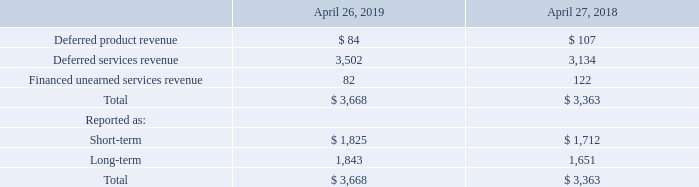Deferred revenue and financed unearned services revenue (in millions):
The following table summarizes the components of our deferred revenue and financed unearned services balance as reported in our consolidated balance sheets (in millions):
Deferred product revenue represents unrecognized revenue related to undelivered product commitments and other product deliveries that have not met all revenue recognition criteria. Deferred services revenue represents customer payments made in advance for services, which include software and hardware maintenance contracts and other services. Financed unearned services revenue represents undelivered services for which cash has been received under certain third-party financing arrangements. See Note 18 – Commitments and Contingencies for additional information related to these arrangements
Which years does the company provide information for components of the company's deferred revenue and financed unearned services balance? 2019, 2018. What does deferred product revenue represent? Unrecognized revenue related to undelivered product commitments and other product deliveries that have not met all revenue recognition criteria. What was the financed unearned services revenue in 2019?
Answer scale should be: million. 82. How many years did financed unearned services revenue exceed $100 million? 2018
Answer: 1. What was the change in deferred services revenue between 2018 and 2019?
Answer scale should be: million. 3,502-3,134
Answer: 368. What was the percentage change in revenues reported as long-term between 2018 and 2019?
Answer scale should be: percent. (1,843-1,651)/1,651
Answer: 11.63. 